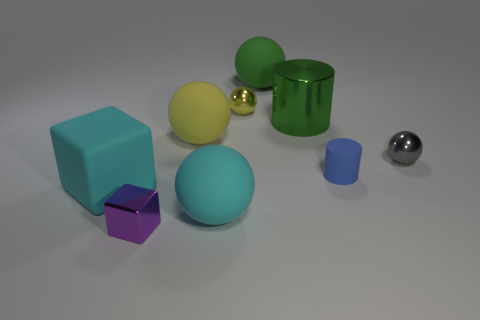Is there any other thing that has the same material as the blue cylinder?
Keep it short and to the point. Yes. There is a big block; is it the same color as the large sphere in front of the gray sphere?
Give a very brief answer. Yes. There is a blue thing that is to the left of the tiny metal sphere in front of the big yellow sphere; are there any cylinders that are behind it?
Provide a succinct answer. Yes. Is the number of blue matte objects that are behind the small yellow ball less than the number of green balls?
Keep it short and to the point. Yes. What number of other things are the same shape as the large yellow thing?
Offer a very short reply. 4. What number of objects are spheres that are behind the blue rubber cylinder or tiny balls that are left of the gray ball?
Your answer should be very brief. 4. How big is the shiny object that is both behind the small purple block and in front of the large green metallic thing?
Give a very brief answer. Small. There is a cyan object right of the cyan block; is its shape the same as the large green metallic object?
Provide a succinct answer. No. What size is the metallic ball that is behind the large green object in front of the shiny sphere to the left of the blue matte cylinder?
Provide a succinct answer. Small. What is the size of the ball that is the same color as the big cylinder?
Your response must be concise. Large. 